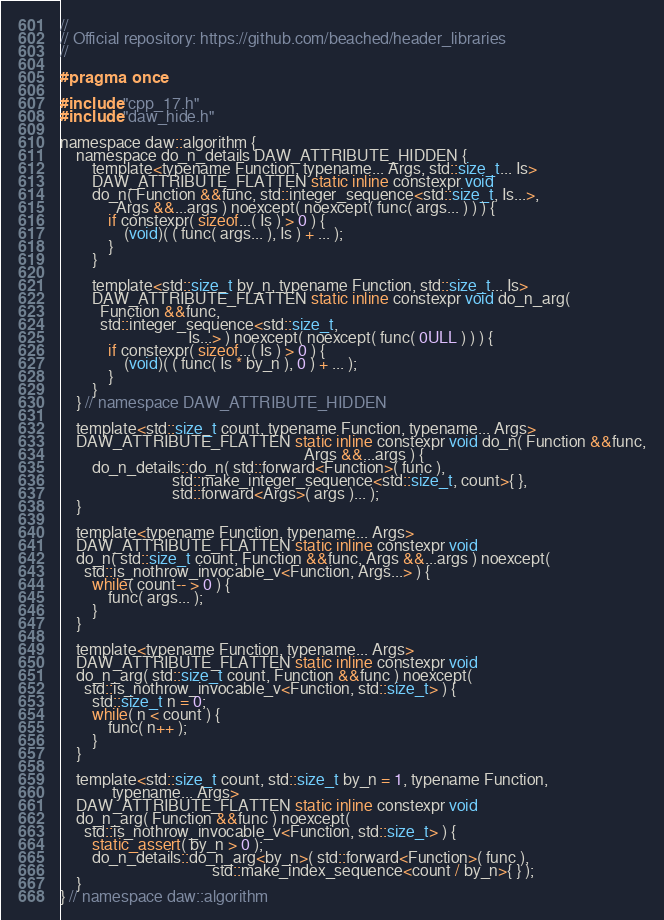Convert code to text. <code><loc_0><loc_0><loc_500><loc_500><_C_>//
// Official repository: https://github.com/beached/header_libraries
//

#pragma once

#include "cpp_17.h"
#include "daw_hide.h"

namespace daw::algorithm {
	namespace do_n_details DAW_ATTRIBUTE_HIDDEN {
		template<typename Function, typename... Args, std::size_t... Is>
		DAW_ATTRIBUTE_FLATTEN static inline constexpr void
		do_n( Function &&func, std::integer_sequence<std::size_t, Is...>,
		      Args &&...args ) noexcept( noexcept( func( args... ) ) ) {
			if constexpr( sizeof...( Is ) > 0 ) {
				(void)( ( func( args... ), Is ) + ... );
			}
		}

		template<std::size_t by_n, typename Function, std::size_t... Is>
		DAW_ATTRIBUTE_FLATTEN static inline constexpr void do_n_arg(
		  Function &&func,
		  std::integer_sequence<std::size_t,
		                        Is...> ) noexcept( noexcept( func( 0ULL ) ) ) {
			if constexpr( sizeof...( Is ) > 0 ) {
				(void)( ( func( Is * by_n ), 0 ) + ... );
			}
		}
	} // namespace DAW_ATTRIBUTE_HIDDEN

	template<std::size_t count, typename Function, typename... Args>
	DAW_ATTRIBUTE_FLATTEN static inline constexpr void do_n( Function &&func,
	                                                         Args &&...args ) {
		do_n_details::do_n( std::forward<Function>( func ),
		                    std::make_integer_sequence<std::size_t, count>{ },
		                    std::forward<Args>( args )... );
	}

	template<typename Function, typename... Args>
	DAW_ATTRIBUTE_FLATTEN static inline constexpr void
	do_n( std::size_t count, Function &&func, Args &&...args ) noexcept(
	  std::is_nothrow_invocable_v<Function, Args...> ) {
		while( count-- > 0 ) {
			func( args... );
		}
	}

	template<typename Function, typename... Args>
	DAW_ATTRIBUTE_FLATTEN static inline constexpr void
	do_n_arg( std::size_t count, Function &&func ) noexcept(
	  std::is_nothrow_invocable_v<Function, std::size_t> ) {
		std::size_t n = 0;
		while( n < count ) {
			func( n++ );
		}
	}

	template<std::size_t count, std::size_t by_n = 1, typename Function,
	         typename... Args>
	DAW_ATTRIBUTE_FLATTEN static inline constexpr void
	do_n_arg( Function &&func ) noexcept(
	  std::is_nothrow_invocable_v<Function, std::size_t> ) {
		static_assert( by_n > 0 );
		do_n_details::do_n_arg<by_n>( std::forward<Function>( func ),
		                              std::make_index_sequence<count / by_n>{ } );
	}
} // namespace daw::algorithm
</code> 